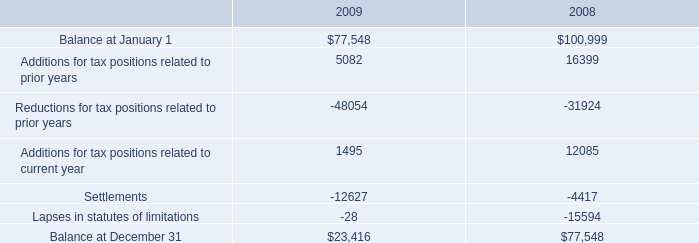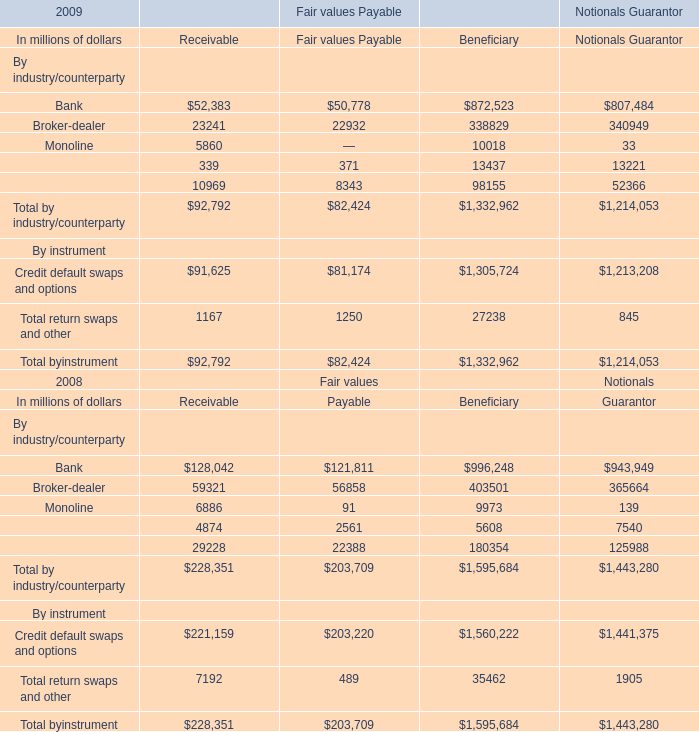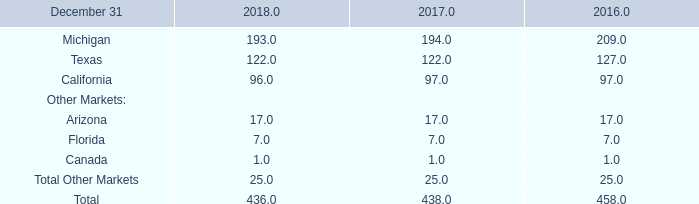What is the total amount of Additions for tax positions related to prior years of 2008, and Credit default swaps and options By instrument of Notionals Guarantor ? 
Computations: (16399.0 + 1213208.0)
Answer: 1229607.0. 